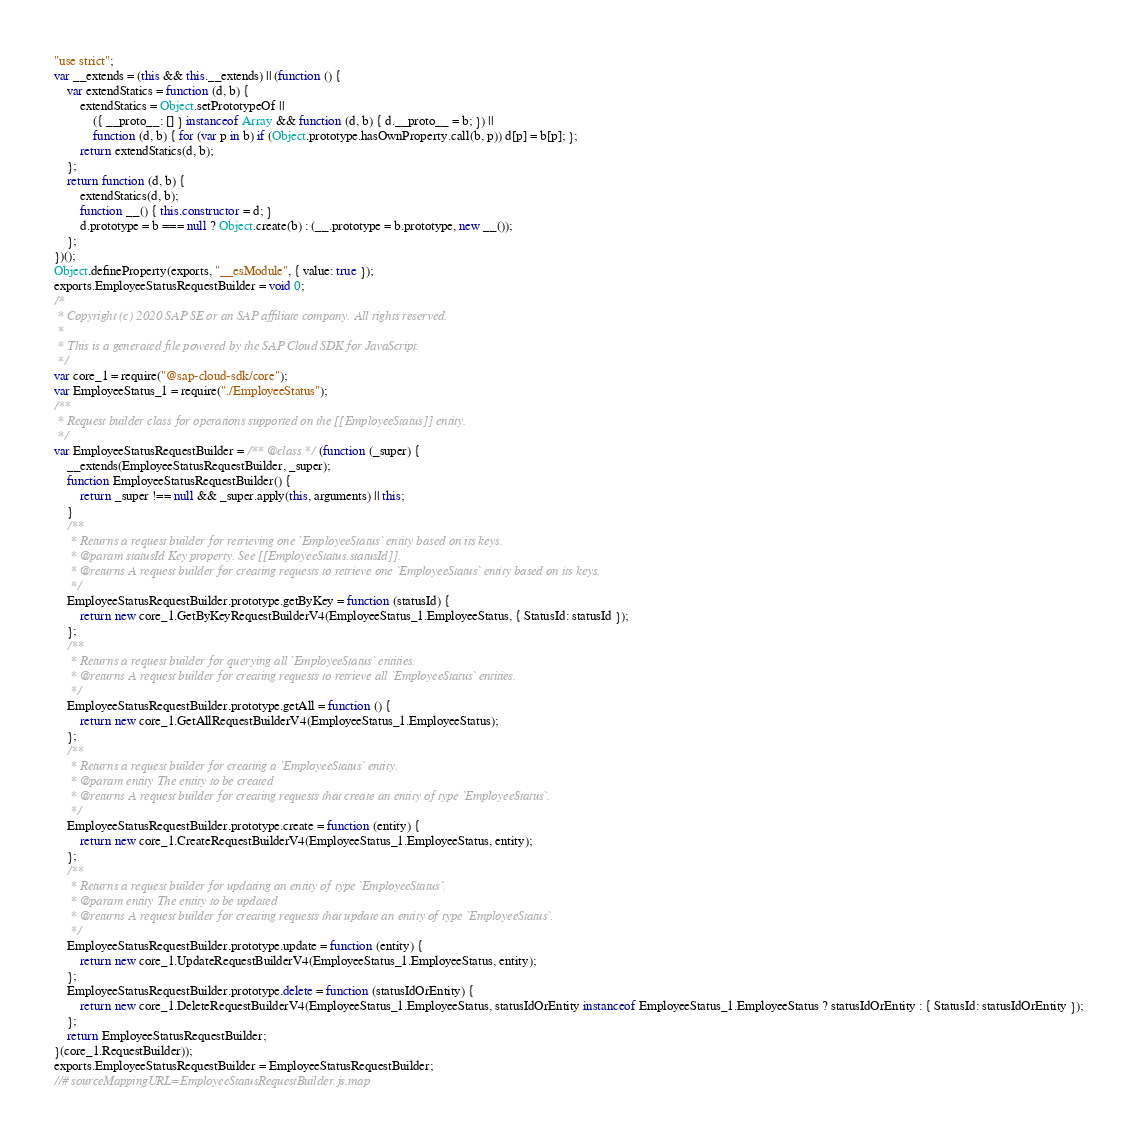<code> <loc_0><loc_0><loc_500><loc_500><_JavaScript_>"use strict";
var __extends = (this && this.__extends) || (function () {
    var extendStatics = function (d, b) {
        extendStatics = Object.setPrototypeOf ||
            ({ __proto__: [] } instanceof Array && function (d, b) { d.__proto__ = b; }) ||
            function (d, b) { for (var p in b) if (Object.prototype.hasOwnProperty.call(b, p)) d[p] = b[p]; };
        return extendStatics(d, b);
    };
    return function (d, b) {
        extendStatics(d, b);
        function __() { this.constructor = d; }
        d.prototype = b === null ? Object.create(b) : (__.prototype = b.prototype, new __());
    };
})();
Object.defineProperty(exports, "__esModule", { value: true });
exports.EmployeeStatusRequestBuilder = void 0;
/*
 * Copyright (c) 2020 SAP SE or an SAP affiliate company. All rights reserved.
 *
 * This is a generated file powered by the SAP Cloud SDK for JavaScript.
 */
var core_1 = require("@sap-cloud-sdk/core");
var EmployeeStatus_1 = require("./EmployeeStatus");
/**
 * Request builder class for operations supported on the [[EmployeeStatus]] entity.
 */
var EmployeeStatusRequestBuilder = /** @class */ (function (_super) {
    __extends(EmployeeStatusRequestBuilder, _super);
    function EmployeeStatusRequestBuilder() {
        return _super !== null && _super.apply(this, arguments) || this;
    }
    /**
     * Returns a request builder for retrieving one `EmployeeStatus` entity based on its keys.
     * @param statusId Key property. See [[EmployeeStatus.statusId]].
     * @returns A request builder for creating requests to retrieve one `EmployeeStatus` entity based on its keys.
     */
    EmployeeStatusRequestBuilder.prototype.getByKey = function (statusId) {
        return new core_1.GetByKeyRequestBuilderV4(EmployeeStatus_1.EmployeeStatus, { StatusId: statusId });
    };
    /**
     * Returns a request builder for querying all `EmployeeStatus` entities.
     * @returns A request builder for creating requests to retrieve all `EmployeeStatus` entities.
     */
    EmployeeStatusRequestBuilder.prototype.getAll = function () {
        return new core_1.GetAllRequestBuilderV4(EmployeeStatus_1.EmployeeStatus);
    };
    /**
     * Returns a request builder for creating a `EmployeeStatus` entity.
     * @param entity The entity to be created
     * @returns A request builder for creating requests that create an entity of type `EmployeeStatus`.
     */
    EmployeeStatusRequestBuilder.prototype.create = function (entity) {
        return new core_1.CreateRequestBuilderV4(EmployeeStatus_1.EmployeeStatus, entity);
    };
    /**
     * Returns a request builder for updating an entity of type `EmployeeStatus`.
     * @param entity The entity to be updated
     * @returns A request builder for creating requests that update an entity of type `EmployeeStatus`.
     */
    EmployeeStatusRequestBuilder.prototype.update = function (entity) {
        return new core_1.UpdateRequestBuilderV4(EmployeeStatus_1.EmployeeStatus, entity);
    };
    EmployeeStatusRequestBuilder.prototype.delete = function (statusIdOrEntity) {
        return new core_1.DeleteRequestBuilderV4(EmployeeStatus_1.EmployeeStatus, statusIdOrEntity instanceof EmployeeStatus_1.EmployeeStatus ? statusIdOrEntity : { StatusId: statusIdOrEntity });
    };
    return EmployeeStatusRequestBuilder;
}(core_1.RequestBuilder));
exports.EmployeeStatusRequestBuilder = EmployeeStatusRequestBuilder;
//# sourceMappingURL=EmployeeStatusRequestBuilder.js.map</code> 